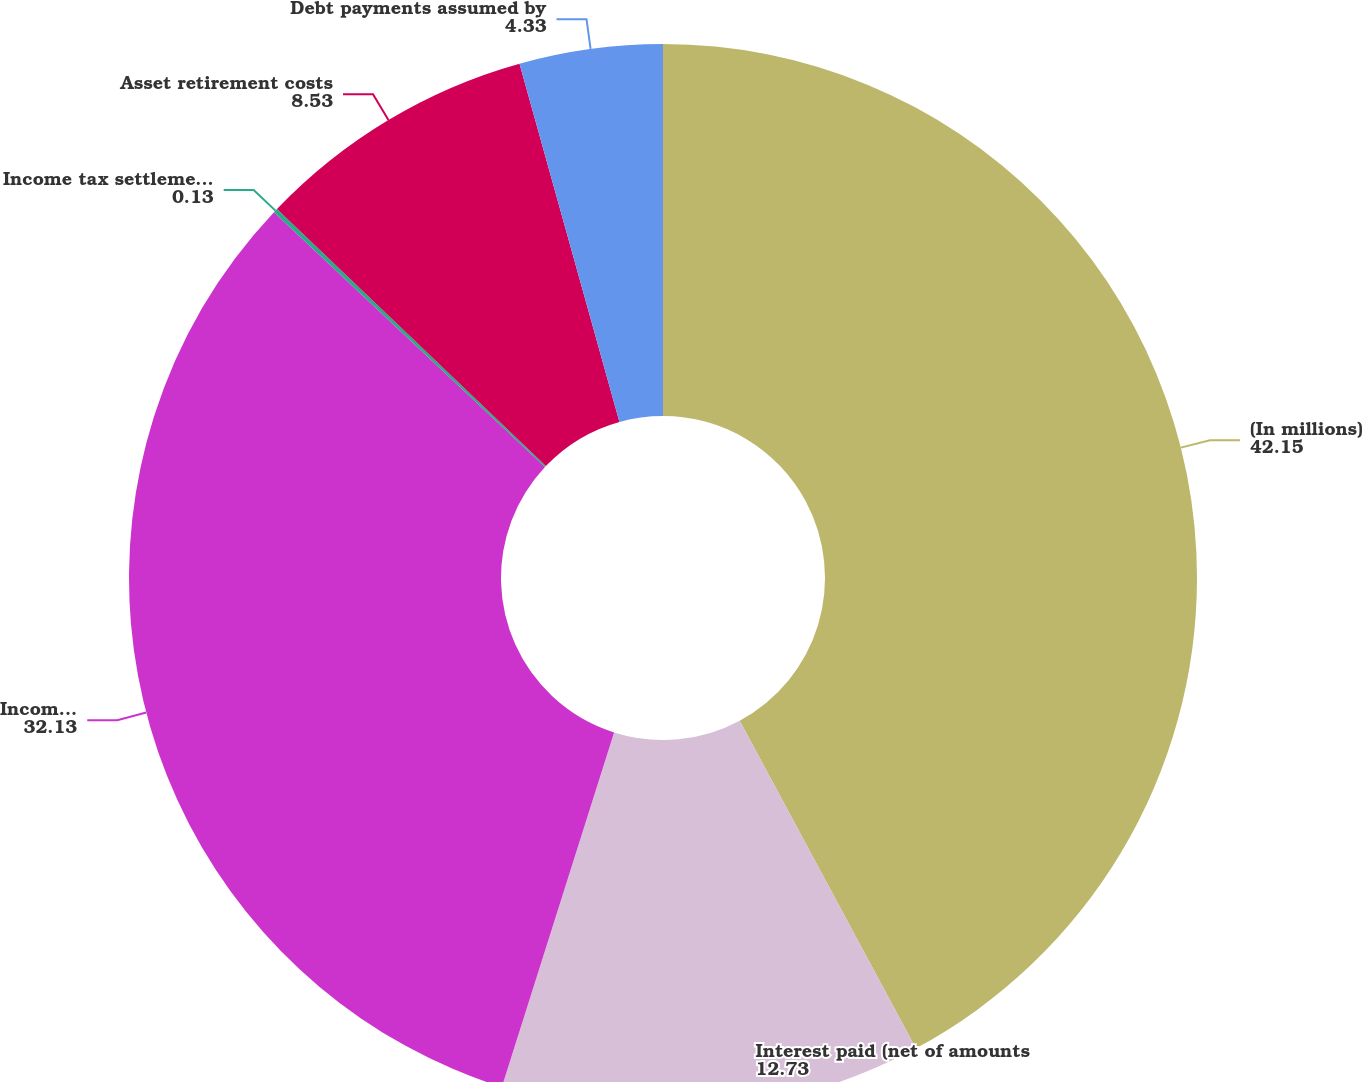Convert chart to OTSL. <chart><loc_0><loc_0><loc_500><loc_500><pie_chart><fcel>(In millions)<fcel>Interest paid (net of amounts<fcel>Income taxes paid to taxing<fcel>Income tax settlements paid to<fcel>Asset retirement costs<fcel>Debt payments assumed by<nl><fcel>42.15%<fcel>12.73%<fcel>32.13%<fcel>0.13%<fcel>8.53%<fcel>4.33%<nl></chart> 